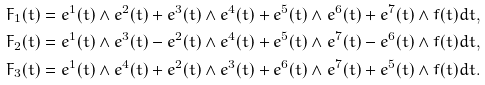Convert formula to latex. <formula><loc_0><loc_0><loc_500><loc_500>F _ { 1 } ( t ) = e ^ { 1 } ( t ) \wedge e ^ { 2 } ( t ) + e ^ { 3 } ( t ) \wedge e ^ { 4 } ( t ) + e ^ { 5 } ( t ) \wedge e ^ { 6 } ( t ) + e ^ { 7 } ( t ) \wedge f ( t ) d t , \\ F _ { 2 } ( t ) = e ^ { 1 } ( t ) \wedge e ^ { 3 } ( t ) - e ^ { 2 } ( t ) \wedge e ^ { 4 } ( t ) + e ^ { 5 } ( t ) \wedge e ^ { 7 } ( t ) - e ^ { 6 } ( t ) \wedge f ( t ) d t , \\ F _ { 3 } ( t ) = e ^ { 1 } ( t ) \wedge e ^ { 4 } ( t ) + e ^ { 2 } ( t ) \wedge e ^ { 3 } ( t ) + e ^ { 6 } ( t ) \wedge e ^ { 7 } ( t ) + e ^ { 5 } ( t ) \wedge f ( t ) d t .</formula> 